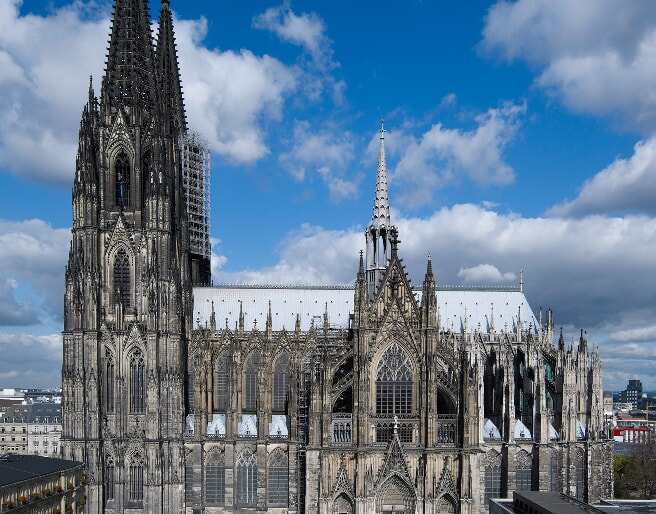Given the architectural grandeur of the Cologne Cathedral, how would you describe it to someone who has never seen it? Imagine a colossal structure rising majestically towards the sky, its twin spires piercing the heavens, casting long shadows over the land. The Cologne Cathedral is an awe-inspiring Gothic masterpiece that leaves an indelible impression. As you stand before it, you're greeted by a facade teeming with intricate sculptures and carvings, each telling a story steeped in centuries of history. The dark stone walls, once harbingers of solemnity, now stand aged yet resilient, each etch and crevice a testament to the passage of time. Step inside, and the lofty ceilings, supported by delicate flying buttresses, sweep you into a serene and sacred atmosphere. Rays of sunlight filter through the richly colored stained-glass windows, casting ephemeral rainbows upon the cold stone floor. The grandeur is not just in its scale, but in the harmony of its details - every arch, every buttress, every spire is a part of a divine symphony of stone and glass, orchestrated to lift the human spirit closer to the divine. Describe a day in the life of a worker building the Cologne Cathedral during medieval times. In the medieval era, a day in the life of a worker building the Cologne Cathedral would begin at dawn. The first light of day would see builders, masons, and artisans gathering at the construction site, each skilled in their craft yet working in unison like the cogs of a grand machine. Imagine the mason, gripping his chisel, shaping immense blocks of stone with precision and care, the rhythmic sounds of hammer on stone echoing through the morning air. The master builder, overseeing the progress, would consult detailed plans, ensuring each component aligns perfectly. Carpenters would craft wooden frames and scaffolds, while glassmakers might melt and shape the brilliant stained glass that would one day illuminate the halls. By midday, a brief respite for a meal of bread, cheese, and perhaps ale - sustenance to fuel their laborious tasks. The air would be thick with the scent of mortar, stone dust clinging to their clothing and hair, while conversations and laughter reflect their camaraderie and shared sense of purpose. As the sun sets, the weary yet proud workers would leave the site, their daily toil inching the monumental structure closer to completion. Each day was a step in a grand legacy, a chapter in the making of a timeless marvel. Envision an alternative reality where the Cologne Cathedral is a towering futuristic building, how might it look? In an alternative reality where the Cologne Cathedral is a towering futuristic building, picture a structure of unparalleled innovation. The traditional Gothic elements would be reimagined with ultramodern materials—soaring spires made of sleek, reflective metals that shimmer in the light, reaching even higher than their historical counterparts. The stone walls are replaced with translucent composites that allow light to flood the vast interiors, creating an ethereal glow. Imagine the flying buttresses transformed into sweeping arcs of bioluminescent structures that pulse with ambient light, supporting the cathedral while emitting a serene phosphorescent glow. The stained-glass windows would be interactive digital screens, displaying dynamic scenes of history or abstract art that evolve continuously. Inside, the vast nave could house floating platforms and walkways, giving visitors an unparalleled view of the soaring heights and intricate details, enhanced by augmented reality guides. Gravity-defying towers would be boldly designed, merging aesthetics with cutting-edge engineering, creating a dendritic effect that harmonizes with the landscape. This futuristic cathedral isn’t just a place of worship but a beacon of technological and architectural marvel, blending spirituality with the advancements of human ingenuity. 